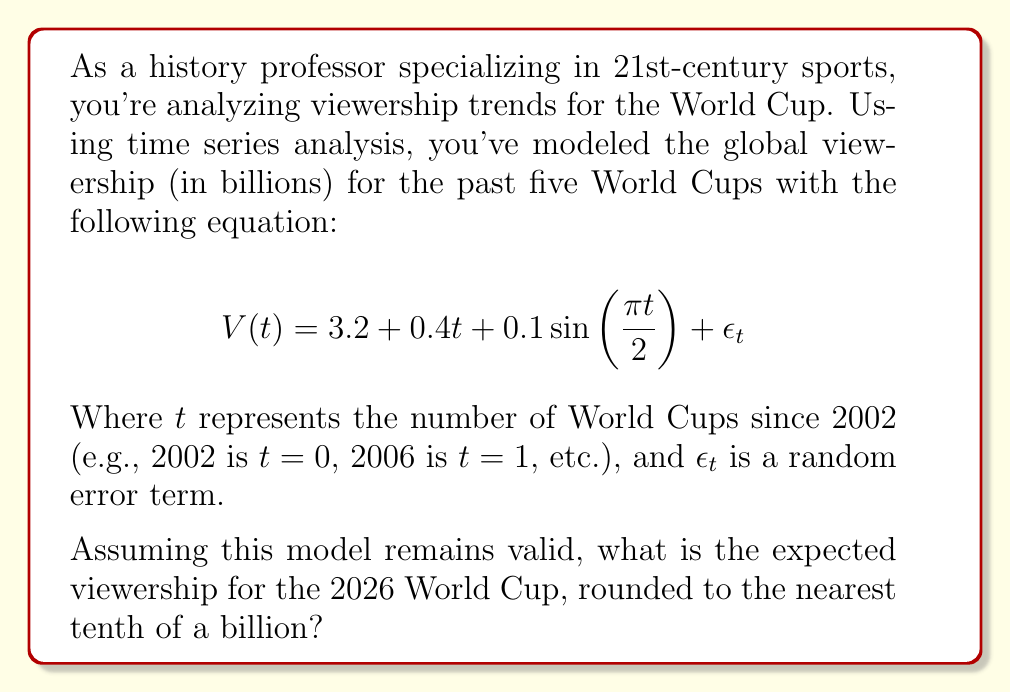Solve this math problem. Let's approach this step-by-step:

1) First, we need to determine what value of $t$ corresponds to the 2026 World Cup.
   - 2002 is $t=0$
   - 2006 is $t=1$
   - 2010 is $t=2$
   - 2014 is $t=3$
   - 2018 is $t=4$
   - 2022 is $t=5$
   - 2026 is $t=6$

2) Now, we can plug $t=6$ into our equation:
   $$V(6) = 3.2 + 0.4(6) + 0.1\sin(\frac{\pi 6}{2}) + \epsilon_6$$

3) Let's solve each part:
   - $3.2$ is constant
   - $0.4(6) = 2.4$
   - $0.1\sin(\frac{\pi 6}{2}) = 0.1\sin(3\pi) = 0$ (since $\sin(3\pi) = 0$)
   - We ignore $\epsilon_6$ as it's a random error term and we're looking for the expected value

4) Adding these together:
   $$V(6) = 3.2 + 2.4 + 0 = 5.6$$

5) Rounding to the nearest tenth of a billion:
   $5.6$ billion

Therefore, the expected viewership for the 2026 World Cup is 5.6 billion.
Answer: 5.6 billion 